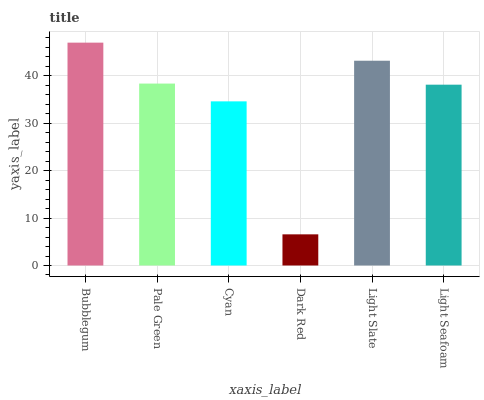Is Pale Green the minimum?
Answer yes or no. No. Is Pale Green the maximum?
Answer yes or no. No. Is Bubblegum greater than Pale Green?
Answer yes or no. Yes. Is Pale Green less than Bubblegum?
Answer yes or no. Yes. Is Pale Green greater than Bubblegum?
Answer yes or no. No. Is Bubblegum less than Pale Green?
Answer yes or no. No. Is Pale Green the high median?
Answer yes or no. Yes. Is Light Seafoam the low median?
Answer yes or no. Yes. Is Cyan the high median?
Answer yes or no. No. Is Bubblegum the low median?
Answer yes or no. No. 